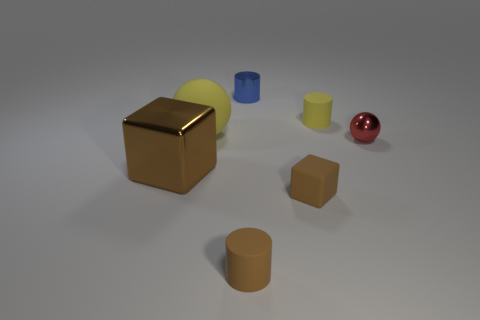What number of things are rubber cylinders behind the brown shiny thing or brown cylinders?
Your answer should be compact. 2. The object that is the same color as the matte ball is what shape?
Provide a succinct answer. Cylinder. What material is the tiny cylinder that is behind the small matte thing that is behind the large block?
Offer a terse response. Metal. Are there any small spheres made of the same material as the blue cylinder?
Provide a succinct answer. Yes. Are there any big yellow spheres that are behind the big thing that is in front of the tiny red metal sphere?
Ensure brevity in your answer.  Yes. There is a small cylinder that is in front of the red metallic thing; what material is it?
Provide a succinct answer. Rubber. Is the red thing the same shape as the large yellow matte object?
Your answer should be compact. Yes. There is a tiny rubber cylinder that is right of the brown block that is right of the yellow rubber thing in front of the small yellow cylinder; what color is it?
Offer a very short reply. Yellow. What number of other red shiny things have the same shape as the red metal thing?
Offer a very short reply. 0. There is a rubber cylinder that is on the left side of the tiny brown matte object right of the tiny blue metallic cylinder; what size is it?
Make the answer very short. Small. 